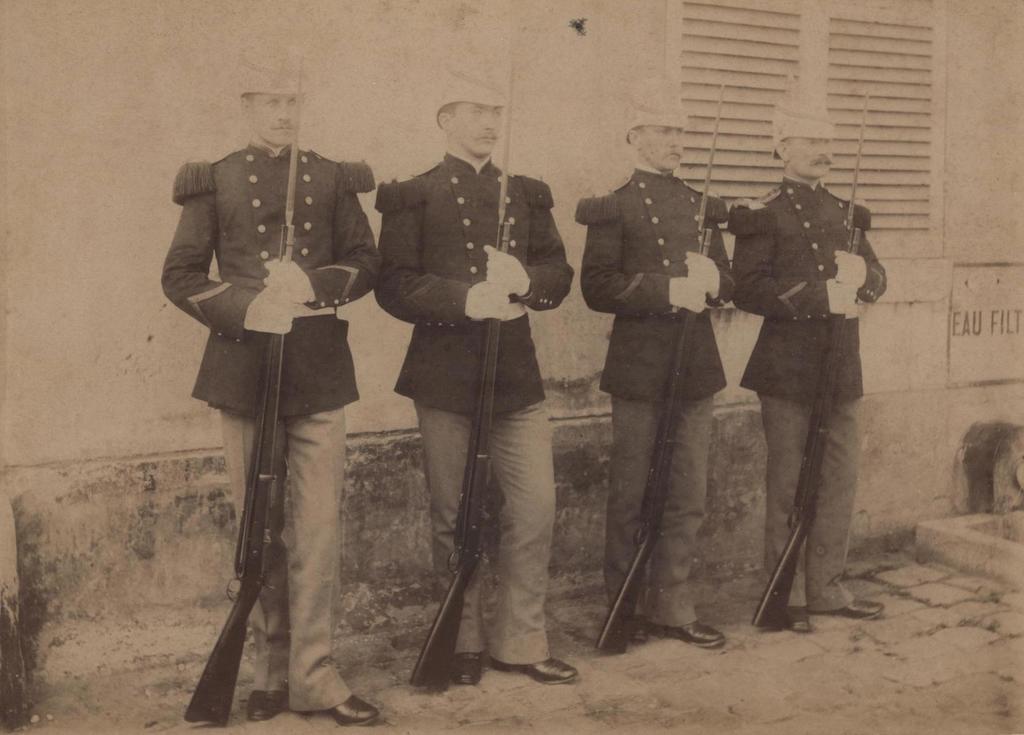How would you summarize this image in a sentence or two? This is a black and white image. 4 men are standing wearing uniform and holding guns. There is a window behind them. 